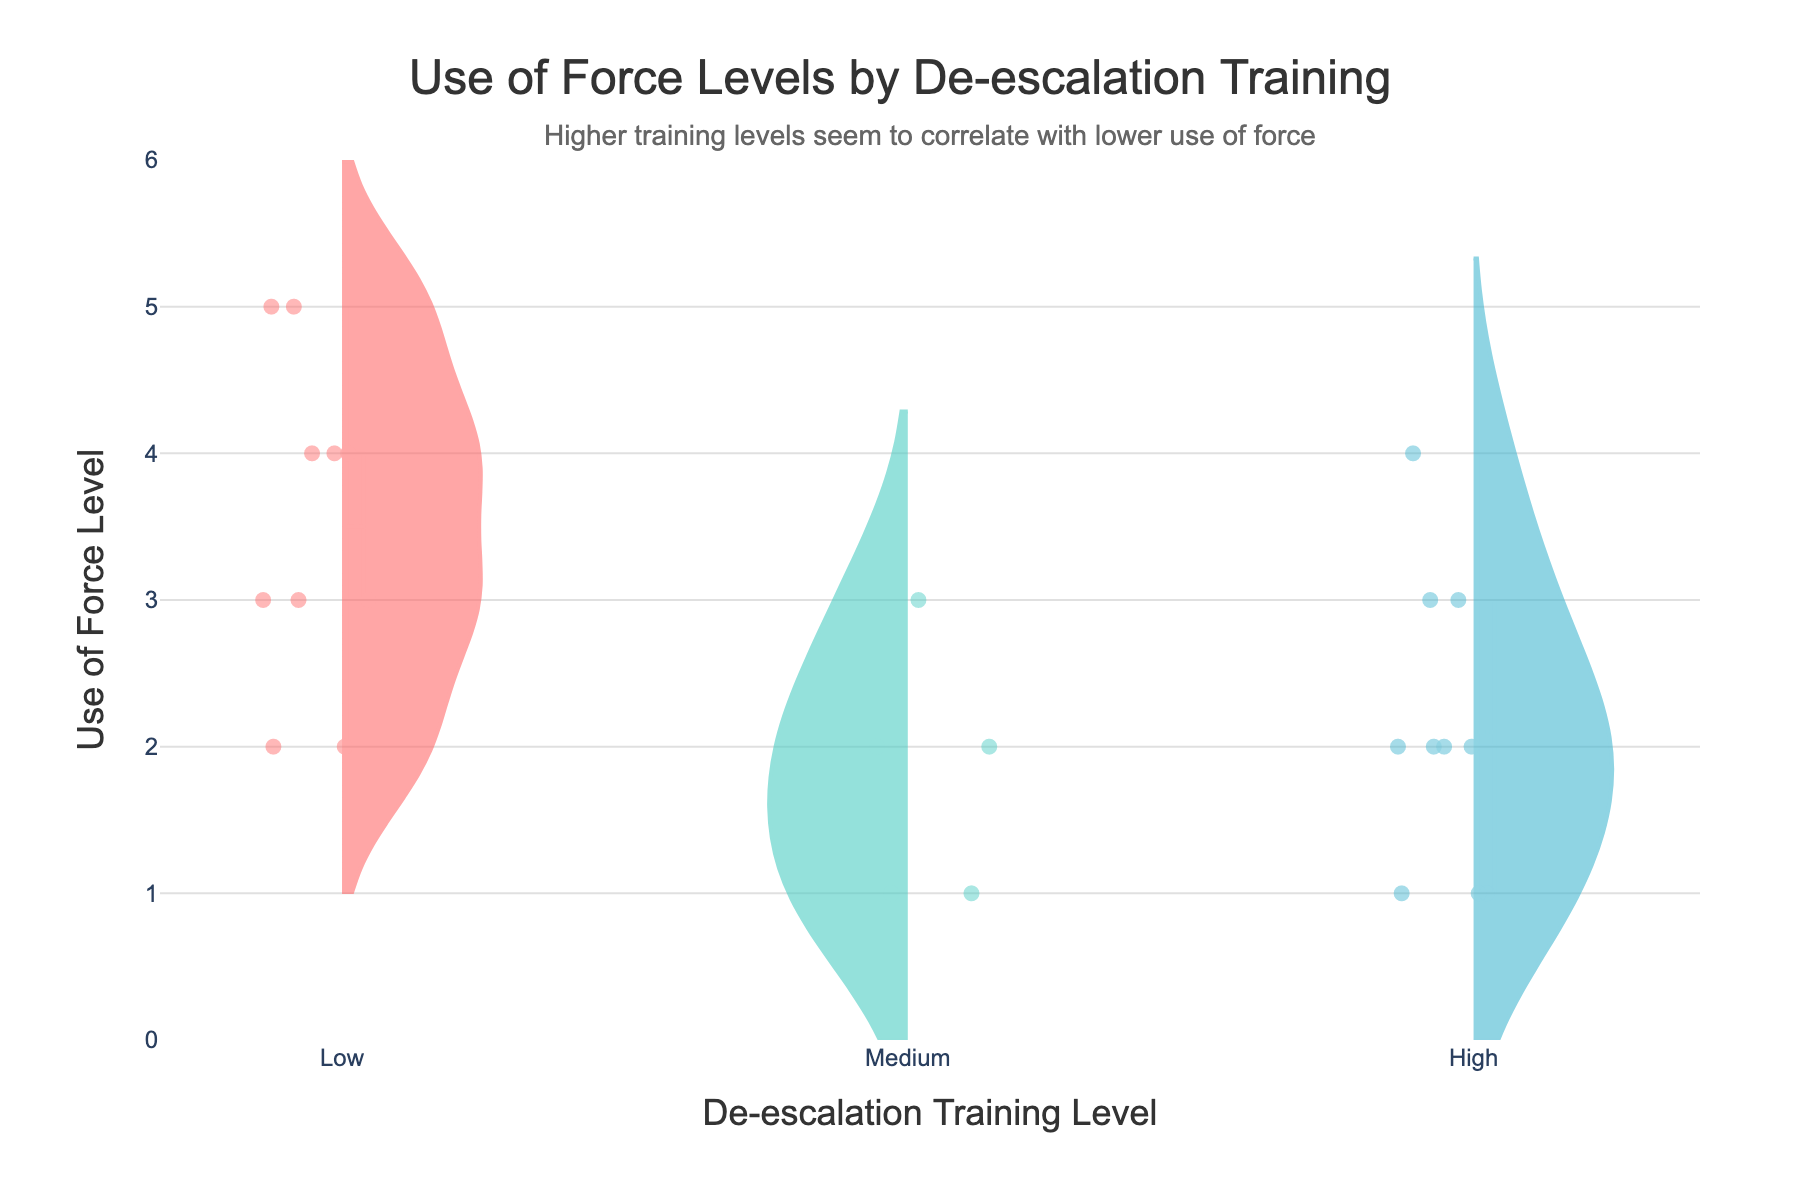What is the title of the figure? The title is usually located at the top of the figure and indicates the main subject of the plot. In this case, it's "Use of Force Levels by De-escalation Training"
Answer: Use of Force Levels by De-escalation Training Which color represents high de-escalation training? Each color in the plot is associated with a specific training level. Checking the color legend for the different levels: #45B7D1 represents the High level.
Answer: Blue How many neighborhoods are analyzed in the plot? Counting the unique neighborhoods listed in the data gives the total number of neighborhoods analyzed in the plot. Downtown, Uptown, Midtown, Suburb, Riverside equals 5 neighborhoods.
Answer: 5 What is the range of Use of Force Levels shown in the plot? The y-axis shows the range of the Use of Force Levels. From the data and visual, it ranges from 1 to 5. The y-axis visually denotes levels from 1 to 5.
Answer: 1 to 5 Which de-escalation training level shows the lowest median Use of Force Level? Medians can be visualized by identifying the center line in the box part of each violin plot. High de-escalation training visually shows the lowest median.
Answer: High Comparing the High and Low de-escalation training levels, which displays a wider range of Use of Force Levels? The range can be observed visually by looking at the length of the violin plots. Low de-escalation training covers from approximately 2 to 5, while high covers a smaller range from approximately 1 to 3.
Answer: Low What is the annotation's main message? Annotations usually provide additional comments or insights on the figure. Here, it's written at the top: "Higher training levels seem to correlate with lower use of force"
Answer: Higher training levels seem to correlate with lower use of force Are outliers included in the violin plots? Outliers are typically visualized in violin plots as individual points marked with dots. Here, they are shown as points distributed around the curves.
Answer: Yes Which neighborhood has incidents with the highest use of force levels? From the data provided, neighborhoods with the highest levels (i.e., level 5) include Uptown and Riverside.
Answer: Uptown, Riverside Which de-escalation training level has fewer data points? Once counting the individual points in the figure, one can see the number under Medium which has fewer compared to Low and High. This is because Midtown has five data points, compared to ten points each under Low and High from Uptown and Riverside combined.
Answer: Medium 